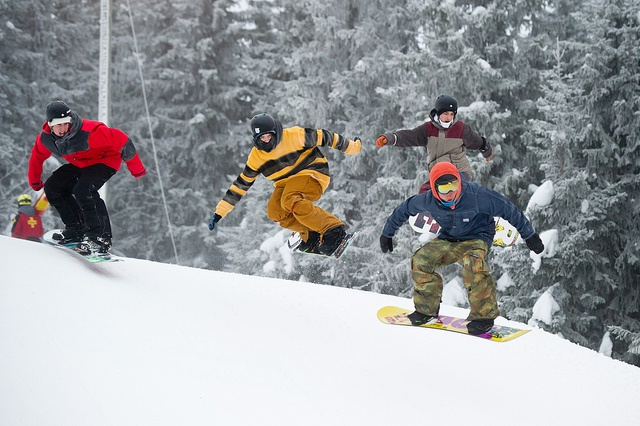Describe the objects in this image and their specific colors. I can see people in gray, black, navy, and darkblue tones, people in gray, black, olive, and orange tones, people in gray, black, and brown tones, people in gray, black, darkgray, and maroon tones, and snowboard in gray, khaki, darkgray, and lightgray tones in this image. 